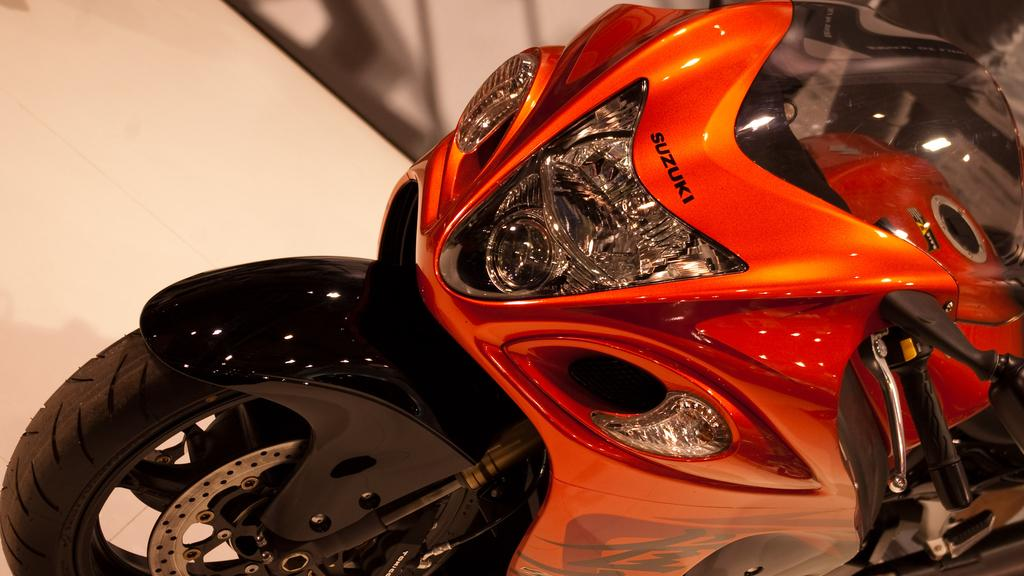What is the main object in the image? There is a bike in the image. What colors can be seen on the bike? The bike has orange and black colors. What feature is present on the bike for illumination? There is a headlight on the bike. What is written or displayed above the headlight? Something is written above the headlight. How many clovers can be seen growing near the bike in the image? There are no clovers visible in the image; it only features a bike with orange and black colors, a headlight, and something written above the headlight. What type of shake is being prepared on the bike in the image? There is no shake or any food preparation visible in the image; it only features a bike with orange and black colors, a headlight, and something written above the headlight. 